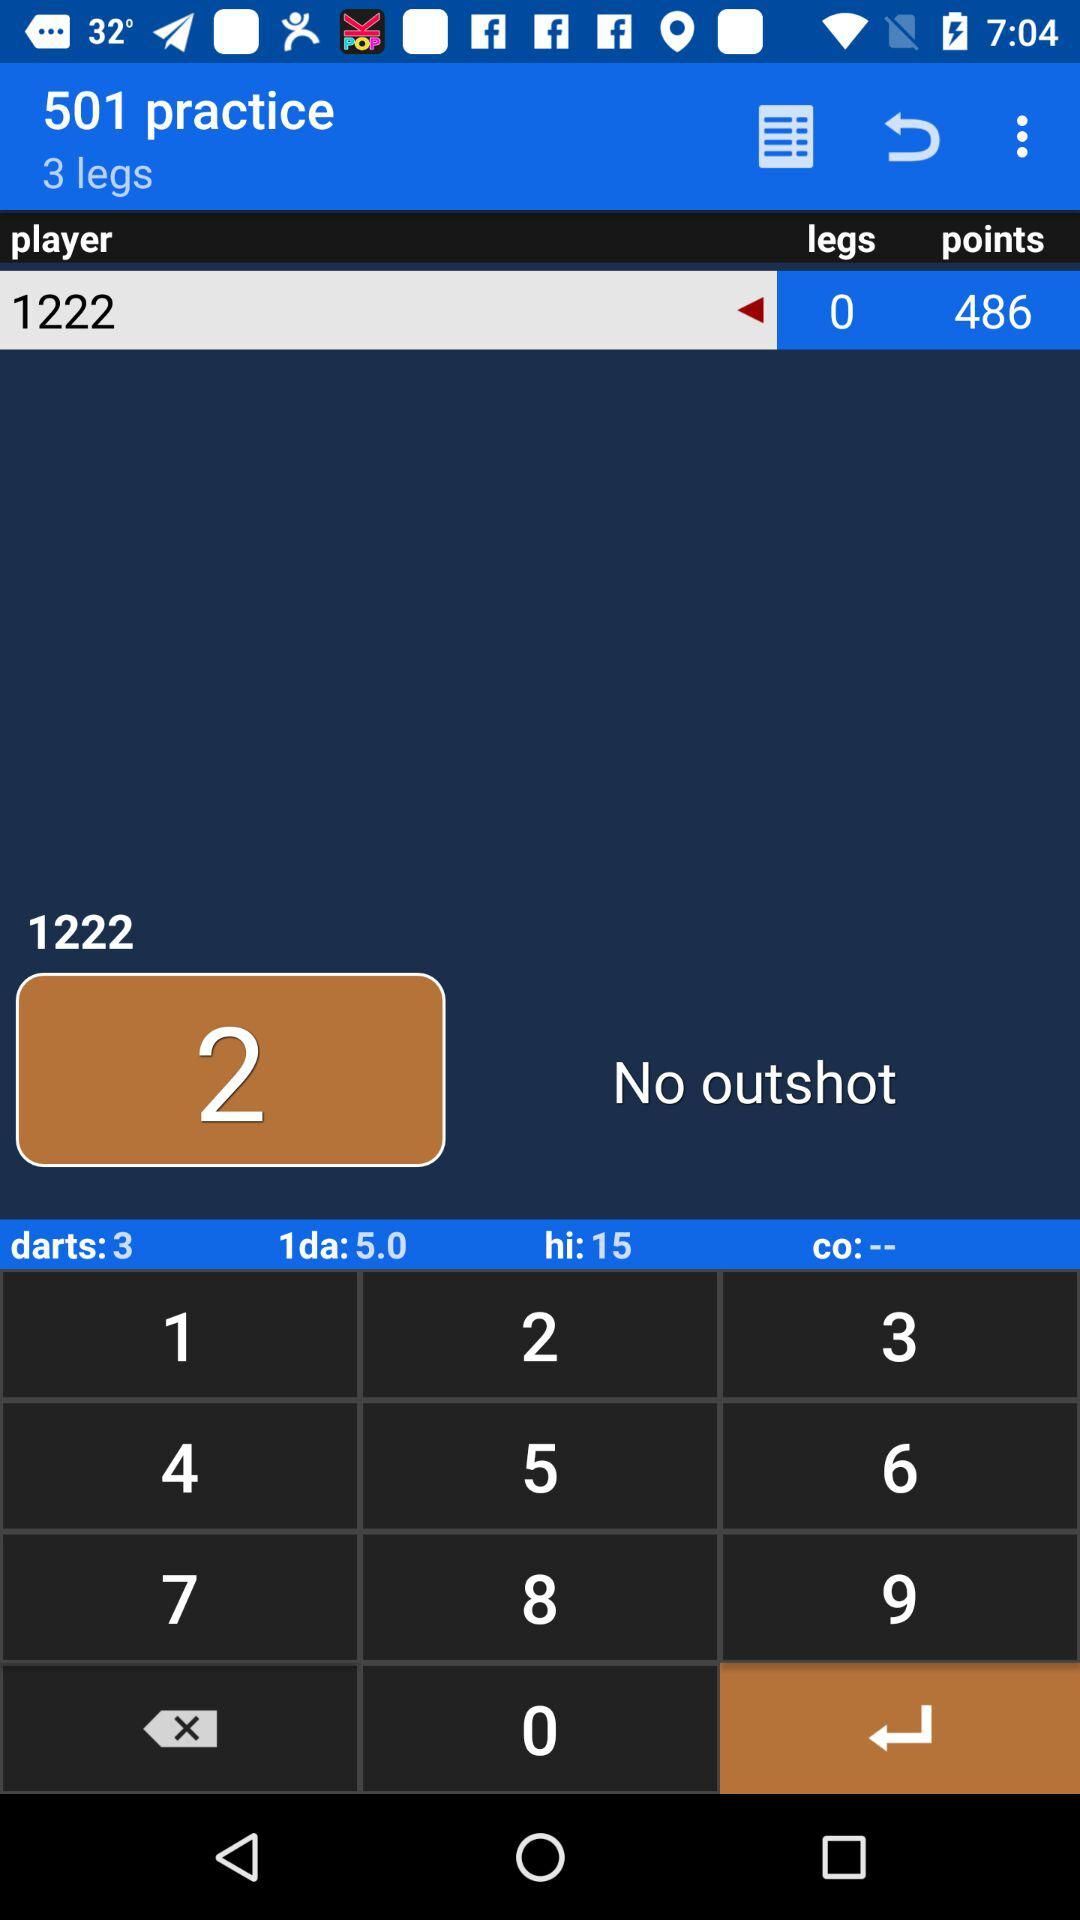What is the player number? The player number is 1222. 